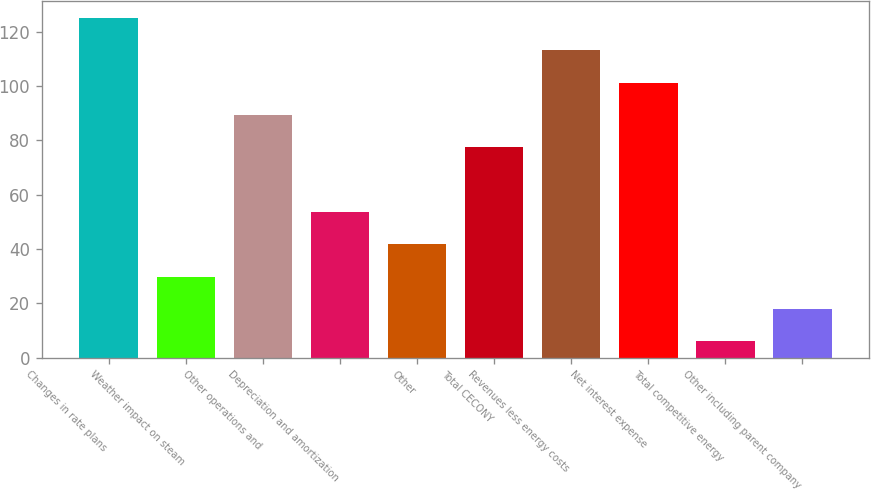Convert chart to OTSL. <chart><loc_0><loc_0><loc_500><loc_500><bar_chart><fcel>Changes in rate plans<fcel>Weather impact on steam<fcel>Other operations and<fcel>Depreciation and amortization<fcel>Other<fcel>Total CECONY<fcel>Revenues less energy costs<fcel>Net interest expense<fcel>Total competitive energy<fcel>Other including parent company<nl><fcel>125<fcel>29.8<fcel>89.3<fcel>53.6<fcel>41.7<fcel>77.4<fcel>113.1<fcel>101.2<fcel>6<fcel>17.9<nl></chart> 